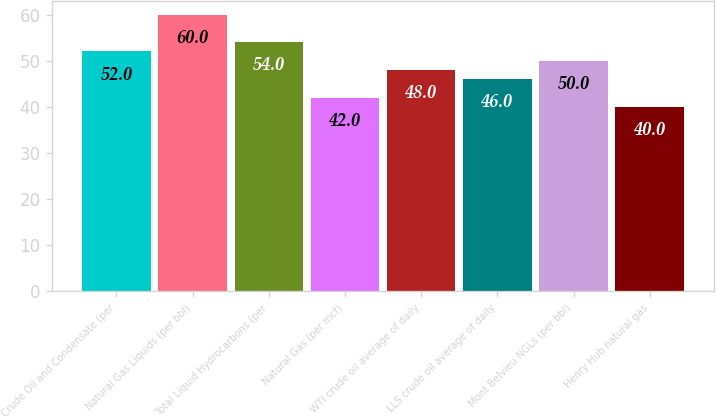Convert chart. <chart><loc_0><loc_0><loc_500><loc_500><bar_chart><fcel>Crude Oil and Condensate (per<fcel>Natural Gas Liquids (per bbl)<fcel>Total Liquid Hydrocarbons (per<fcel>Natural Gas (per mcf)<fcel>WTI crude oil average of daily<fcel>LLS crude oil average of daily<fcel>Mont Belvieu NGLs (per bbl)<fcel>Henry Hub natural gas<nl><fcel>52<fcel>60<fcel>54<fcel>42<fcel>48<fcel>46<fcel>50<fcel>40<nl></chart> 